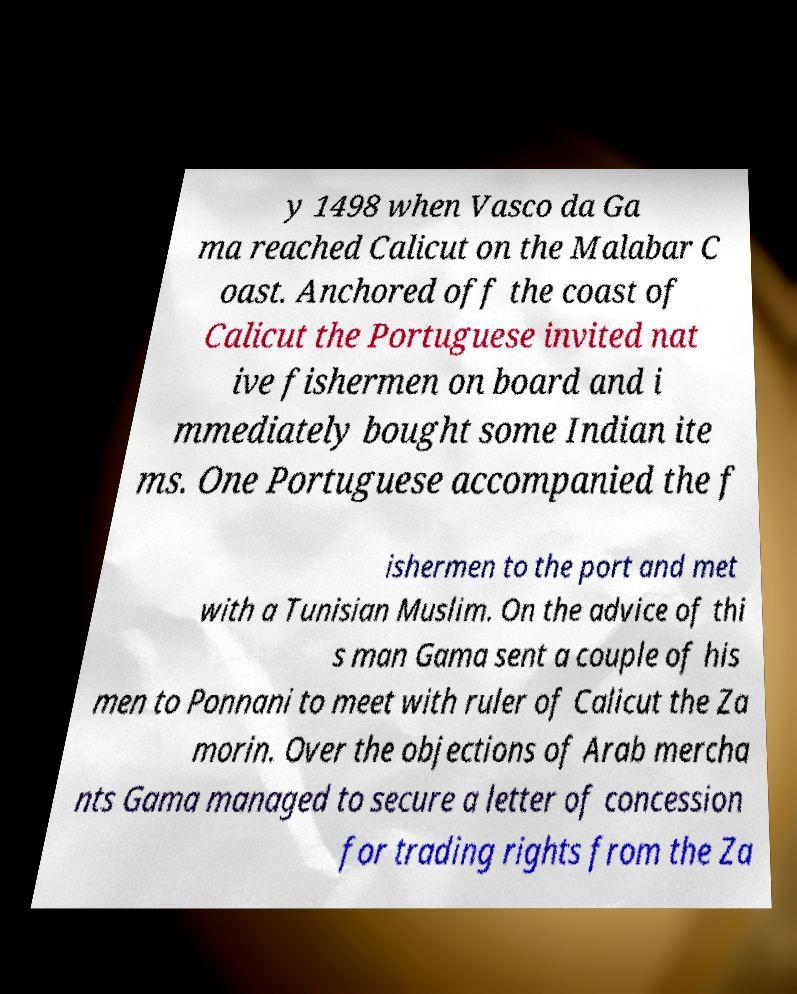I need the written content from this picture converted into text. Can you do that? y 1498 when Vasco da Ga ma reached Calicut on the Malabar C oast. Anchored off the coast of Calicut the Portuguese invited nat ive fishermen on board and i mmediately bought some Indian ite ms. One Portuguese accompanied the f ishermen to the port and met with a Tunisian Muslim. On the advice of thi s man Gama sent a couple of his men to Ponnani to meet with ruler of Calicut the Za morin. Over the objections of Arab mercha nts Gama managed to secure a letter of concession for trading rights from the Za 